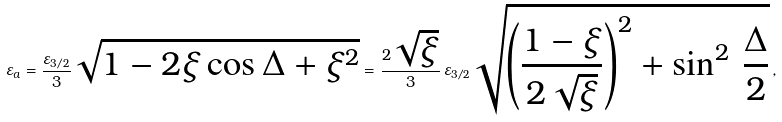Convert formula to latex. <formula><loc_0><loc_0><loc_500><loc_500>\varepsilon _ { a } = \frac { \varepsilon _ { 3 / 2 } } { 3 } \sqrt { 1 - 2 \xi \cos \Delta + \xi ^ { 2 } } = \frac { 2 \sqrt { \xi } } { 3 } \, \varepsilon _ { 3 / 2 } \sqrt { \left ( \frac { 1 - \xi } { 2 \sqrt { \xi } } \right ) ^ { 2 } + \sin ^ { 2 } \, \frac { \Delta } { 2 } } \, ,</formula> 